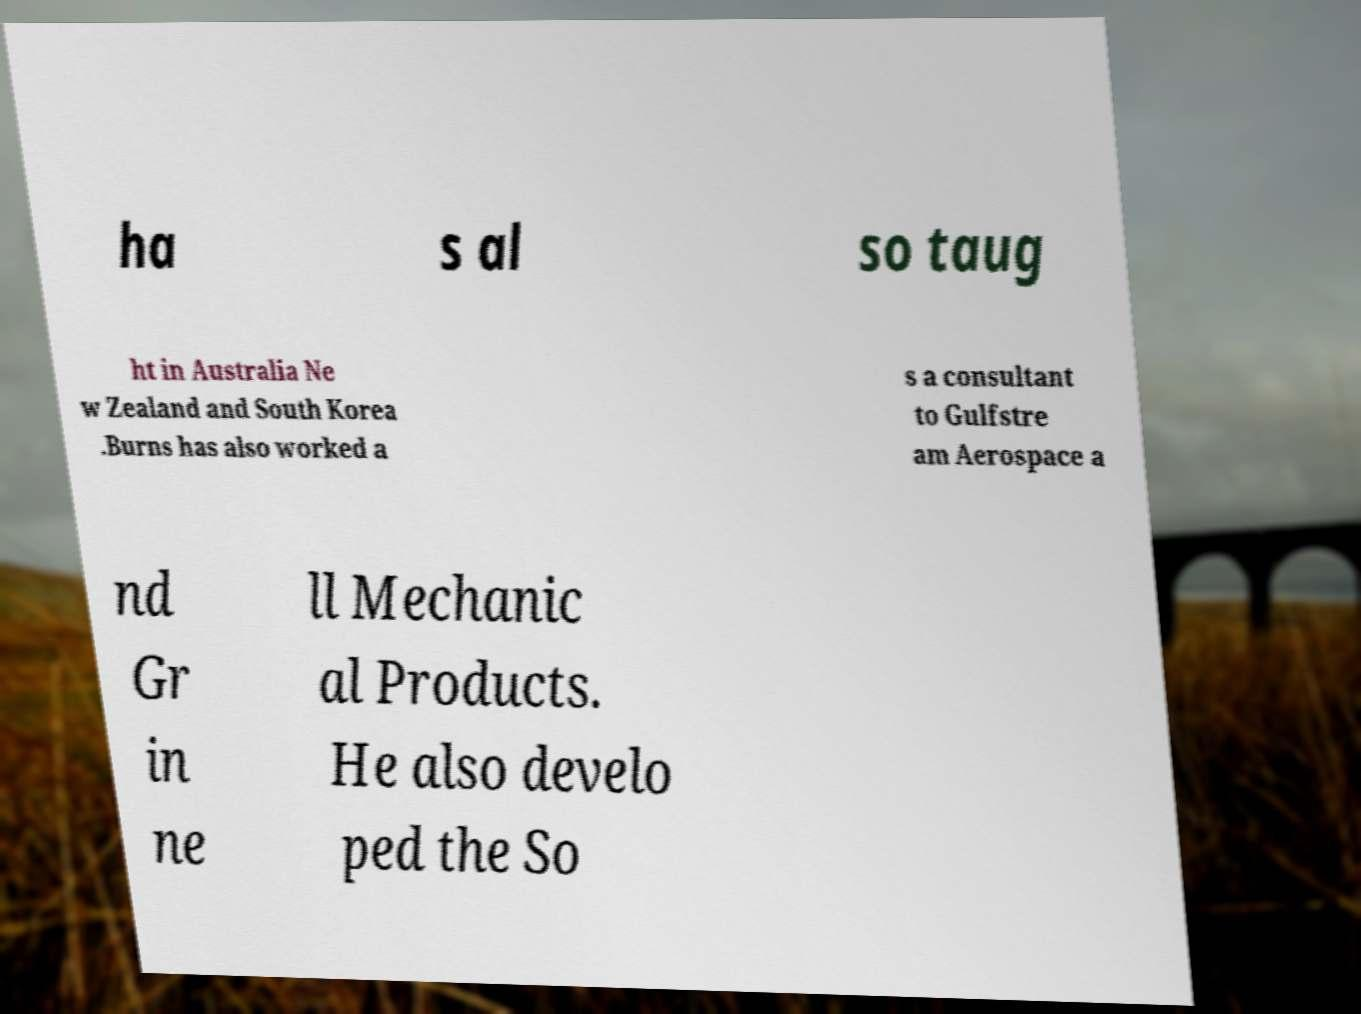There's text embedded in this image that I need extracted. Can you transcribe it verbatim? ha s al so taug ht in Australia Ne w Zealand and South Korea .Burns has also worked a s a consultant to Gulfstre am Aerospace a nd Gr in ne ll Mechanic al Products. He also develo ped the So 